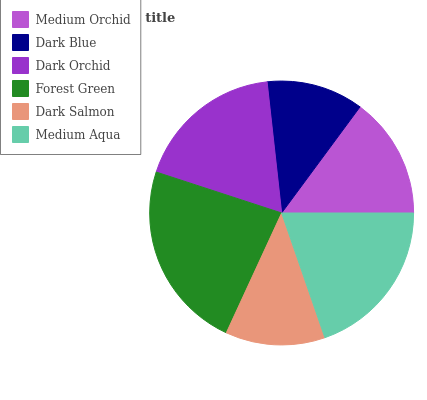Is Dark Blue the minimum?
Answer yes or no. Yes. Is Forest Green the maximum?
Answer yes or no. Yes. Is Dark Orchid the minimum?
Answer yes or no. No. Is Dark Orchid the maximum?
Answer yes or no. No. Is Dark Orchid greater than Dark Blue?
Answer yes or no. Yes. Is Dark Blue less than Dark Orchid?
Answer yes or no. Yes. Is Dark Blue greater than Dark Orchid?
Answer yes or no. No. Is Dark Orchid less than Dark Blue?
Answer yes or no. No. Is Dark Orchid the high median?
Answer yes or no. Yes. Is Medium Orchid the low median?
Answer yes or no. Yes. Is Medium Aqua the high median?
Answer yes or no. No. Is Dark Blue the low median?
Answer yes or no. No. 